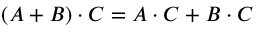Convert formula to latex. <formula><loc_0><loc_0><loc_500><loc_500>( A + B ) \cdot C = A \cdot C + B \cdot C</formula> 